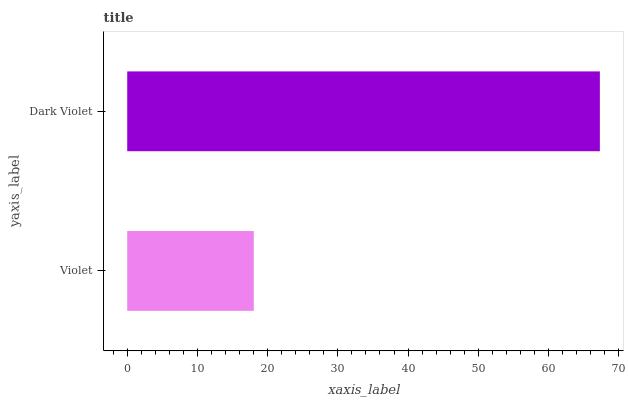Is Violet the minimum?
Answer yes or no. Yes. Is Dark Violet the maximum?
Answer yes or no. Yes. Is Dark Violet the minimum?
Answer yes or no. No. Is Dark Violet greater than Violet?
Answer yes or no. Yes. Is Violet less than Dark Violet?
Answer yes or no. Yes. Is Violet greater than Dark Violet?
Answer yes or no. No. Is Dark Violet less than Violet?
Answer yes or no. No. Is Dark Violet the high median?
Answer yes or no. Yes. Is Violet the low median?
Answer yes or no. Yes. Is Violet the high median?
Answer yes or no. No. Is Dark Violet the low median?
Answer yes or no. No. 